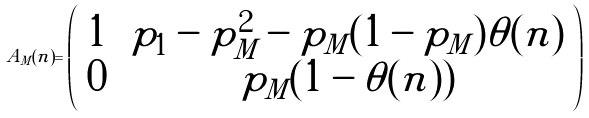<formula> <loc_0><loc_0><loc_500><loc_500>\tilde { A } _ { M } ( n ) = \left ( \begin{array} { c c } 1 & \, p _ { 1 } - p _ { M } ^ { 2 } - p _ { M } ( 1 - p _ { M } ) \theta ( n ) \\ 0 & \, p _ { M } ( 1 - \theta ( n ) ) \end{array} \right )</formula> 